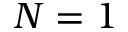Convert formula to latex. <formula><loc_0><loc_0><loc_500><loc_500>N = 1</formula> 